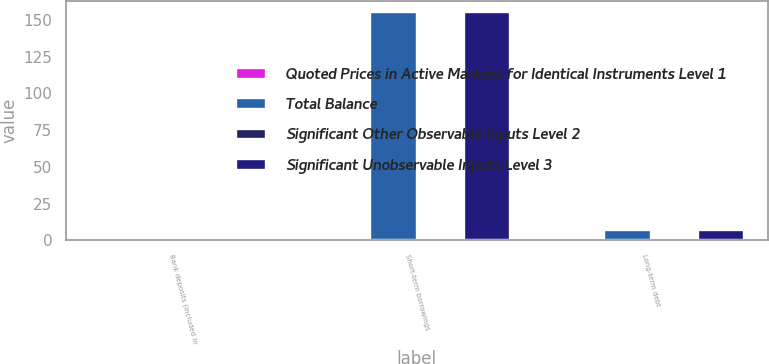<chart> <loc_0><loc_0><loc_500><loc_500><stacked_bar_chart><ecel><fcel>Bank deposits (included in<fcel>Short-term borrowings<fcel>Long-term debt<nl><fcel>Quoted Prices in Active Markets for Identical Instruments Level 1<fcel>0<fcel>0<fcel>0<nl><fcel>Total Balance<fcel>0<fcel>155<fcel>6.8<nl><fcel>Significant Other Observable Inputs Level 2<fcel>0<fcel>0<fcel>0<nl><fcel>Significant Unobservable Inputs Level 3<fcel>0<fcel>155<fcel>6.8<nl></chart> 